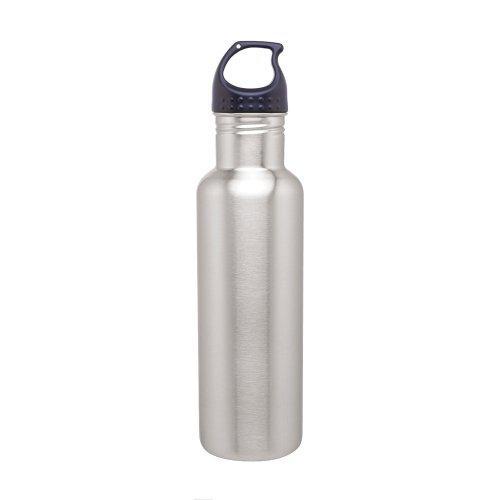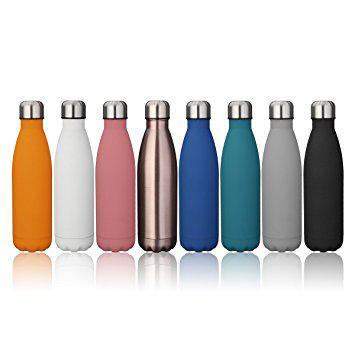The first image is the image on the left, the second image is the image on the right. Given the left and right images, does the statement "There are stainless steel water bottles that are all solid colored." hold true? Answer yes or no. Yes. 